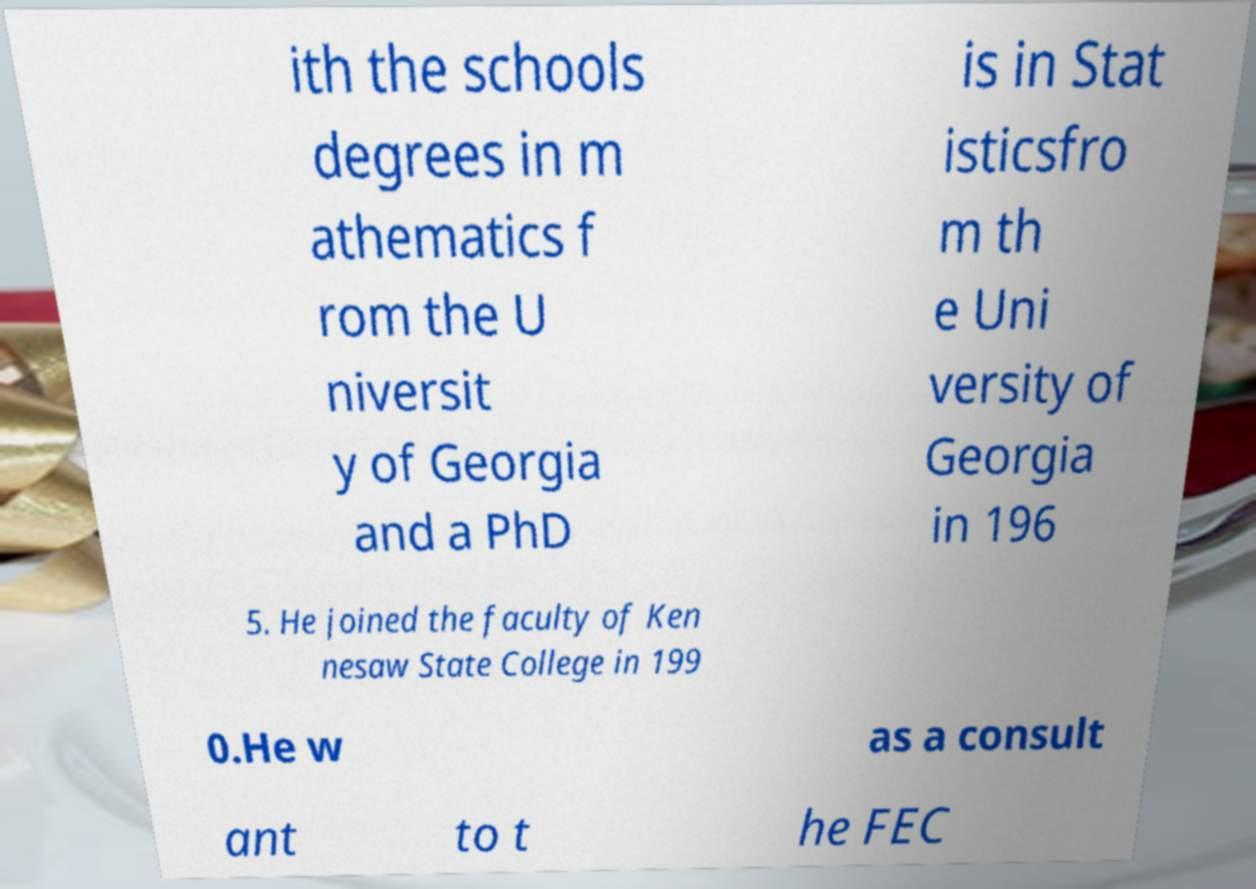Could you extract and type out the text from this image? ith the schools degrees in m athematics f rom the U niversit y of Georgia and a PhD is in Stat isticsfro m th e Uni versity of Georgia in 196 5. He joined the faculty of Ken nesaw State College in 199 0.He w as a consult ant to t he FEC 